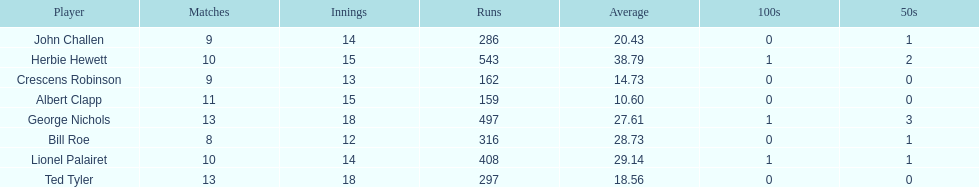How many players played more than 10 matches? 3. 